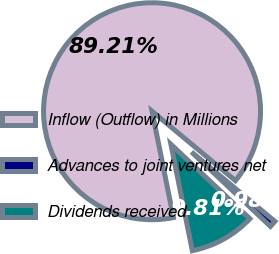<chart> <loc_0><loc_0><loc_500><loc_500><pie_chart><fcel>Inflow (Outflow) in Millions<fcel>Advances to joint ventures net<fcel>Dividends received<nl><fcel>89.21%<fcel>0.98%<fcel>9.81%<nl></chart> 